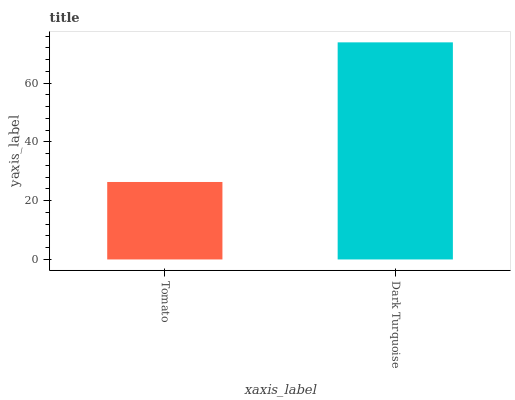Is Tomato the minimum?
Answer yes or no. Yes. Is Dark Turquoise the maximum?
Answer yes or no. Yes. Is Dark Turquoise the minimum?
Answer yes or no. No. Is Dark Turquoise greater than Tomato?
Answer yes or no. Yes. Is Tomato less than Dark Turquoise?
Answer yes or no. Yes. Is Tomato greater than Dark Turquoise?
Answer yes or no. No. Is Dark Turquoise less than Tomato?
Answer yes or no. No. Is Dark Turquoise the high median?
Answer yes or no. Yes. Is Tomato the low median?
Answer yes or no. Yes. Is Tomato the high median?
Answer yes or no. No. Is Dark Turquoise the low median?
Answer yes or no. No. 